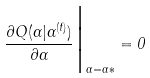Convert formula to latex. <formula><loc_0><loc_0><loc_500><loc_500>\frac { \partial Q ( \alpha | \alpha ^ { ( t ) } ) } { \partial \alpha } \Big | _ { \alpha = \alpha { \ast } } = 0</formula> 